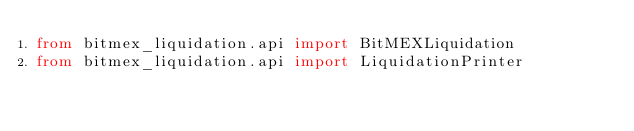Convert code to text. <code><loc_0><loc_0><loc_500><loc_500><_Python_>from bitmex_liquidation.api import BitMEXLiquidation
from bitmex_liquidation.api import LiquidationPrinter
</code> 